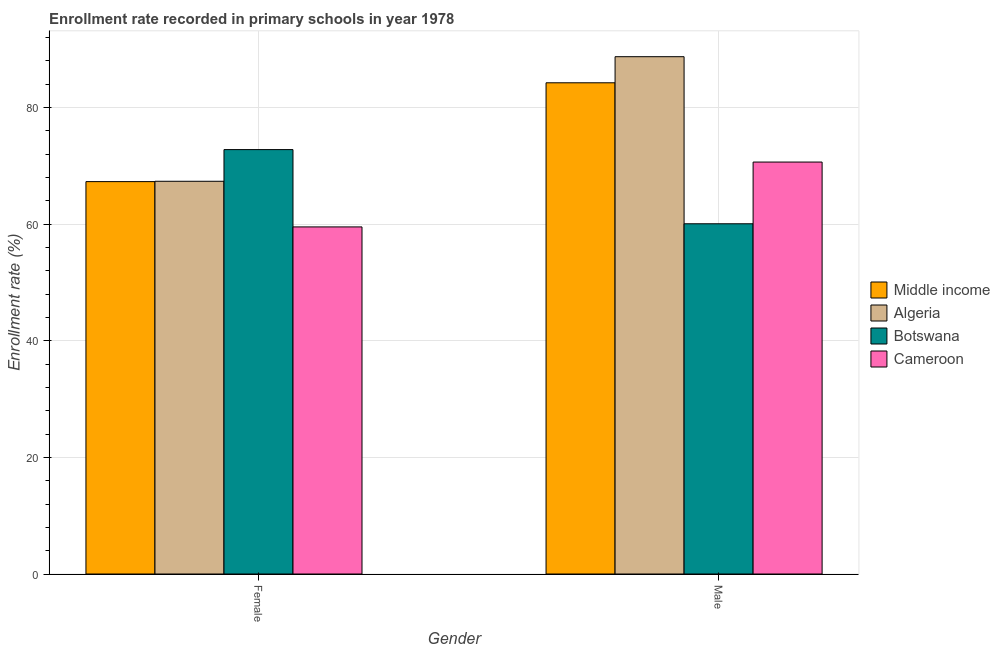How many different coloured bars are there?
Keep it short and to the point. 4. Are the number of bars per tick equal to the number of legend labels?
Provide a succinct answer. Yes. Are the number of bars on each tick of the X-axis equal?
Offer a very short reply. Yes. How many bars are there on the 2nd tick from the left?
Offer a terse response. 4. What is the label of the 1st group of bars from the left?
Your response must be concise. Female. What is the enrollment rate of female students in Cameroon?
Ensure brevity in your answer.  59.52. Across all countries, what is the maximum enrollment rate of male students?
Provide a short and direct response. 88.71. Across all countries, what is the minimum enrollment rate of female students?
Give a very brief answer. 59.52. In which country was the enrollment rate of female students maximum?
Make the answer very short. Botswana. In which country was the enrollment rate of female students minimum?
Make the answer very short. Cameroon. What is the total enrollment rate of female students in the graph?
Give a very brief answer. 266.92. What is the difference between the enrollment rate of male students in Botswana and that in Cameroon?
Keep it short and to the point. -10.58. What is the difference between the enrollment rate of male students in Cameroon and the enrollment rate of female students in Botswana?
Provide a short and direct response. -2.13. What is the average enrollment rate of female students per country?
Offer a very short reply. 66.73. What is the difference between the enrollment rate of male students and enrollment rate of female students in Botswana?
Offer a very short reply. -12.72. In how many countries, is the enrollment rate of male students greater than 64 %?
Offer a very short reply. 3. What is the ratio of the enrollment rate of female students in Algeria to that in Middle income?
Provide a short and direct response. 1. In how many countries, is the enrollment rate of female students greater than the average enrollment rate of female students taken over all countries?
Your response must be concise. 3. What does the 2nd bar from the left in Male represents?
Provide a short and direct response. Algeria. What does the 1st bar from the right in Female represents?
Keep it short and to the point. Cameroon. How many bars are there?
Your answer should be compact. 8. Are all the bars in the graph horizontal?
Your response must be concise. No. What is the difference between two consecutive major ticks on the Y-axis?
Offer a terse response. 20. Are the values on the major ticks of Y-axis written in scientific E-notation?
Your response must be concise. No. Does the graph contain any zero values?
Provide a succinct answer. No. Does the graph contain grids?
Keep it short and to the point. Yes. How many legend labels are there?
Your response must be concise. 4. How are the legend labels stacked?
Your answer should be very brief. Vertical. What is the title of the graph?
Provide a short and direct response. Enrollment rate recorded in primary schools in year 1978. What is the label or title of the X-axis?
Provide a short and direct response. Gender. What is the label or title of the Y-axis?
Offer a terse response. Enrollment rate (%). What is the Enrollment rate (%) of Middle income in Female?
Your response must be concise. 67.29. What is the Enrollment rate (%) in Algeria in Female?
Ensure brevity in your answer.  67.34. What is the Enrollment rate (%) in Botswana in Female?
Offer a terse response. 72.77. What is the Enrollment rate (%) of Cameroon in Female?
Your response must be concise. 59.52. What is the Enrollment rate (%) of Middle income in Male?
Your answer should be very brief. 84.23. What is the Enrollment rate (%) in Algeria in Male?
Provide a short and direct response. 88.71. What is the Enrollment rate (%) of Botswana in Male?
Provide a succinct answer. 60.06. What is the Enrollment rate (%) of Cameroon in Male?
Your answer should be compact. 70.64. Across all Gender, what is the maximum Enrollment rate (%) of Middle income?
Provide a short and direct response. 84.23. Across all Gender, what is the maximum Enrollment rate (%) in Algeria?
Your response must be concise. 88.71. Across all Gender, what is the maximum Enrollment rate (%) of Botswana?
Ensure brevity in your answer.  72.77. Across all Gender, what is the maximum Enrollment rate (%) of Cameroon?
Provide a succinct answer. 70.64. Across all Gender, what is the minimum Enrollment rate (%) of Middle income?
Your response must be concise. 67.29. Across all Gender, what is the minimum Enrollment rate (%) in Algeria?
Keep it short and to the point. 67.34. Across all Gender, what is the minimum Enrollment rate (%) in Botswana?
Provide a succinct answer. 60.06. Across all Gender, what is the minimum Enrollment rate (%) in Cameroon?
Your answer should be compact. 59.52. What is the total Enrollment rate (%) of Middle income in the graph?
Your response must be concise. 151.52. What is the total Enrollment rate (%) in Algeria in the graph?
Keep it short and to the point. 156.05. What is the total Enrollment rate (%) in Botswana in the graph?
Your answer should be compact. 132.83. What is the total Enrollment rate (%) of Cameroon in the graph?
Provide a short and direct response. 130.16. What is the difference between the Enrollment rate (%) in Middle income in Female and that in Male?
Your answer should be very brief. -16.95. What is the difference between the Enrollment rate (%) in Algeria in Female and that in Male?
Ensure brevity in your answer.  -21.36. What is the difference between the Enrollment rate (%) of Botswana in Female and that in Male?
Your response must be concise. 12.72. What is the difference between the Enrollment rate (%) of Cameroon in Female and that in Male?
Ensure brevity in your answer.  -11.12. What is the difference between the Enrollment rate (%) of Middle income in Female and the Enrollment rate (%) of Algeria in Male?
Make the answer very short. -21.42. What is the difference between the Enrollment rate (%) of Middle income in Female and the Enrollment rate (%) of Botswana in Male?
Give a very brief answer. 7.23. What is the difference between the Enrollment rate (%) in Middle income in Female and the Enrollment rate (%) in Cameroon in Male?
Offer a terse response. -3.35. What is the difference between the Enrollment rate (%) in Algeria in Female and the Enrollment rate (%) in Botswana in Male?
Offer a very short reply. 7.29. What is the difference between the Enrollment rate (%) in Algeria in Female and the Enrollment rate (%) in Cameroon in Male?
Offer a very short reply. -3.3. What is the difference between the Enrollment rate (%) in Botswana in Female and the Enrollment rate (%) in Cameroon in Male?
Keep it short and to the point. 2.13. What is the average Enrollment rate (%) of Middle income per Gender?
Your answer should be compact. 75.76. What is the average Enrollment rate (%) in Algeria per Gender?
Give a very brief answer. 78.03. What is the average Enrollment rate (%) of Botswana per Gender?
Provide a succinct answer. 66.42. What is the average Enrollment rate (%) in Cameroon per Gender?
Your response must be concise. 65.08. What is the difference between the Enrollment rate (%) of Middle income and Enrollment rate (%) of Algeria in Female?
Your answer should be compact. -0.06. What is the difference between the Enrollment rate (%) in Middle income and Enrollment rate (%) in Botswana in Female?
Give a very brief answer. -5.49. What is the difference between the Enrollment rate (%) in Middle income and Enrollment rate (%) in Cameroon in Female?
Your answer should be compact. 7.77. What is the difference between the Enrollment rate (%) in Algeria and Enrollment rate (%) in Botswana in Female?
Your answer should be compact. -5.43. What is the difference between the Enrollment rate (%) in Algeria and Enrollment rate (%) in Cameroon in Female?
Keep it short and to the point. 7.83. What is the difference between the Enrollment rate (%) in Botswana and Enrollment rate (%) in Cameroon in Female?
Offer a very short reply. 13.26. What is the difference between the Enrollment rate (%) in Middle income and Enrollment rate (%) in Algeria in Male?
Offer a very short reply. -4.47. What is the difference between the Enrollment rate (%) of Middle income and Enrollment rate (%) of Botswana in Male?
Your response must be concise. 24.17. What is the difference between the Enrollment rate (%) of Middle income and Enrollment rate (%) of Cameroon in Male?
Your answer should be compact. 13.59. What is the difference between the Enrollment rate (%) of Algeria and Enrollment rate (%) of Botswana in Male?
Your answer should be compact. 28.65. What is the difference between the Enrollment rate (%) in Algeria and Enrollment rate (%) in Cameroon in Male?
Ensure brevity in your answer.  18.07. What is the difference between the Enrollment rate (%) in Botswana and Enrollment rate (%) in Cameroon in Male?
Your response must be concise. -10.58. What is the ratio of the Enrollment rate (%) of Middle income in Female to that in Male?
Provide a short and direct response. 0.8. What is the ratio of the Enrollment rate (%) of Algeria in Female to that in Male?
Your answer should be compact. 0.76. What is the ratio of the Enrollment rate (%) of Botswana in Female to that in Male?
Give a very brief answer. 1.21. What is the ratio of the Enrollment rate (%) in Cameroon in Female to that in Male?
Provide a short and direct response. 0.84. What is the difference between the highest and the second highest Enrollment rate (%) of Middle income?
Ensure brevity in your answer.  16.95. What is the difference between the highest and the second highest Enrollment rate (%) of Algeria?
Your answer should be compact. 21.36. What is the difference between the highest and the second highest Enrollment rate (%) in Botswana?
Offer a very short reply. 12.72. What is the difference between the highest and the second highest Enrollment rate (%) of Cameroon?
Your answer should be very brief. 11.12. What is the difference between the highest and the lowest Enrollment rate (%) of Middle income?
Give a very brief answer. 16.95. What is the difference between the highest and the lowest Enrollment rate (%) in Algeria?
Your answer should be very brief. 21.36. What is the difference between the highest and the lowest Enrollment rate (%) of Botswana?
Your response must be concise. 12.72. What is the difference between the highest and the lowest Enrollment rate (%) in Cameroon?
Your response must be concise. 11.12. 